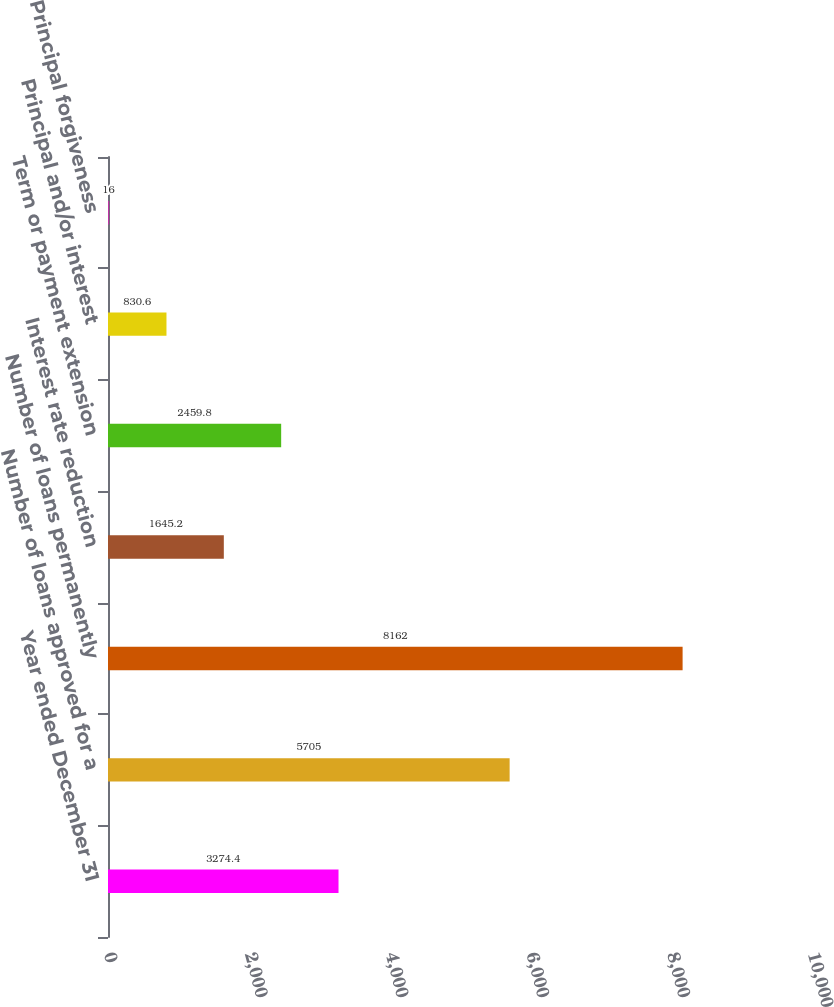Convert chart. <chart><loc_0><loc_0><loc_500><loc_500><bar_chart><fcel>Year ended December 31<fcel>Number of loans approved for a<fcel>Number of loans permanently<fcel>Interest rate reduction<fcel>Term or payment extension<fcel>Principal and/or interest<fcel>Principal forgiveness<nl><fcel>3274.4<fcel>5705<fcel>8162<fcel>1645.2<fcel>2459.8<fcel>830.6<fcel>16<nl></chart> 